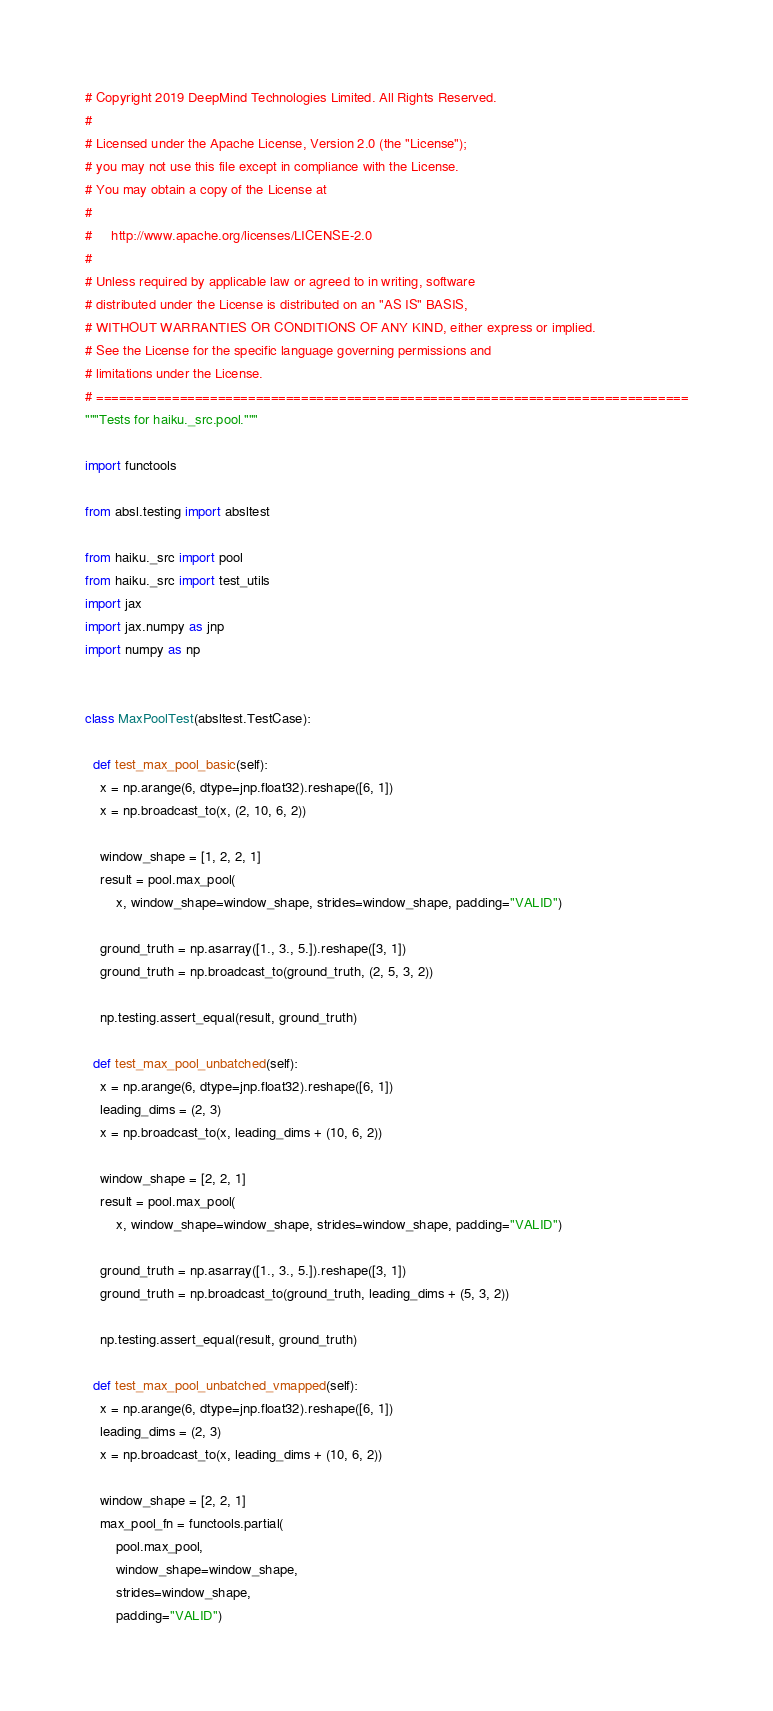<code> <loc_0><loc_0><loc_500><loc_500><_Python_># Copyright 2019 DeepMind Technologies Limited. All Rights Reserved.
#
# Licensed under the Apache License, Version 2.0 (the "License");
# you may not use this file except in compliance with the License.
# You may obtain a copy of the License at
#
#     http://www.apache.org/licenses/LICENSE-2.0
#
# Unless required by applicable law or agreed to in writing, software
# distributed under the License is distributed on an "AS IS" BASIS,
# WITHOUT WARRANTIES OR CONDITIONS OF ANY KIND, either express or implied.
# See the License for the specific language governing permissions and
# limitations under the License.
# ==============================================================================
"""Tests for haiku._src.pool."""

import functools

from absl.testing import absltest

from haiku._src import pool
from haiku._src import test_utils
import jax
import jax.numpy as jnp
import numpy as np


class MaxPoolTest(absltest.TestCase):

  def test_max_pool_basic(self):
    x = np.arange(6, dtype=jnp.float32).reshape([6, 1])
    x = np.broadcast_to(x, (2, 10, 6, 2))

    window_shape = [1, 2, 2, 1]
    result = pool.max_pool(
        x, window_shape=window_shape, strides=window_shape, padding="VALID")

    ground_truth = np.asarray([1., 3., 5.]).reshape([3, 1])
    ground_truth = np.broadcast_to(ground_truth, (2, 5, 3, 2))

    np.testing.assert_equal(result, ground_truth)

  def test_max_pool_unbatched(self):
    x = np.arange(6, dtype=jnp.float32).reshape([6, 1])
    leading_dims = (2, 3)
    x = np.broadcast_to(x, leading_dims + (10, 6, 2))

    window_shape = [2, 2, 1]
    result = pool.max_pool(
        x, window_shape=window_shape, strides=window_shape, padding="VALID")

    ground_truth = np.asarray([1., 3., 5.]).reshape([3, 1])
    ground_truth = np.broadcast_to(ground_truth, leading_dims + (5, 3, 2))

    np.testing.assert_equal(result, ground_truth)

  def test_max_pool_unbatched_vmapped(self):
    x = np.arange(6, dtype=jnp.float32).reshape([6, 1])
    leading_dims = (2, 3)
    x = np.broadcast_to(x, leading_dims + (10, 6, 2))

    window_shape = [2, 2, 1]
    max_pool_fn = functools.partial(
        pool.max_pool,
        window_shape=window_shape,
        strides=window_shape,
        padding="VALID")</code> 